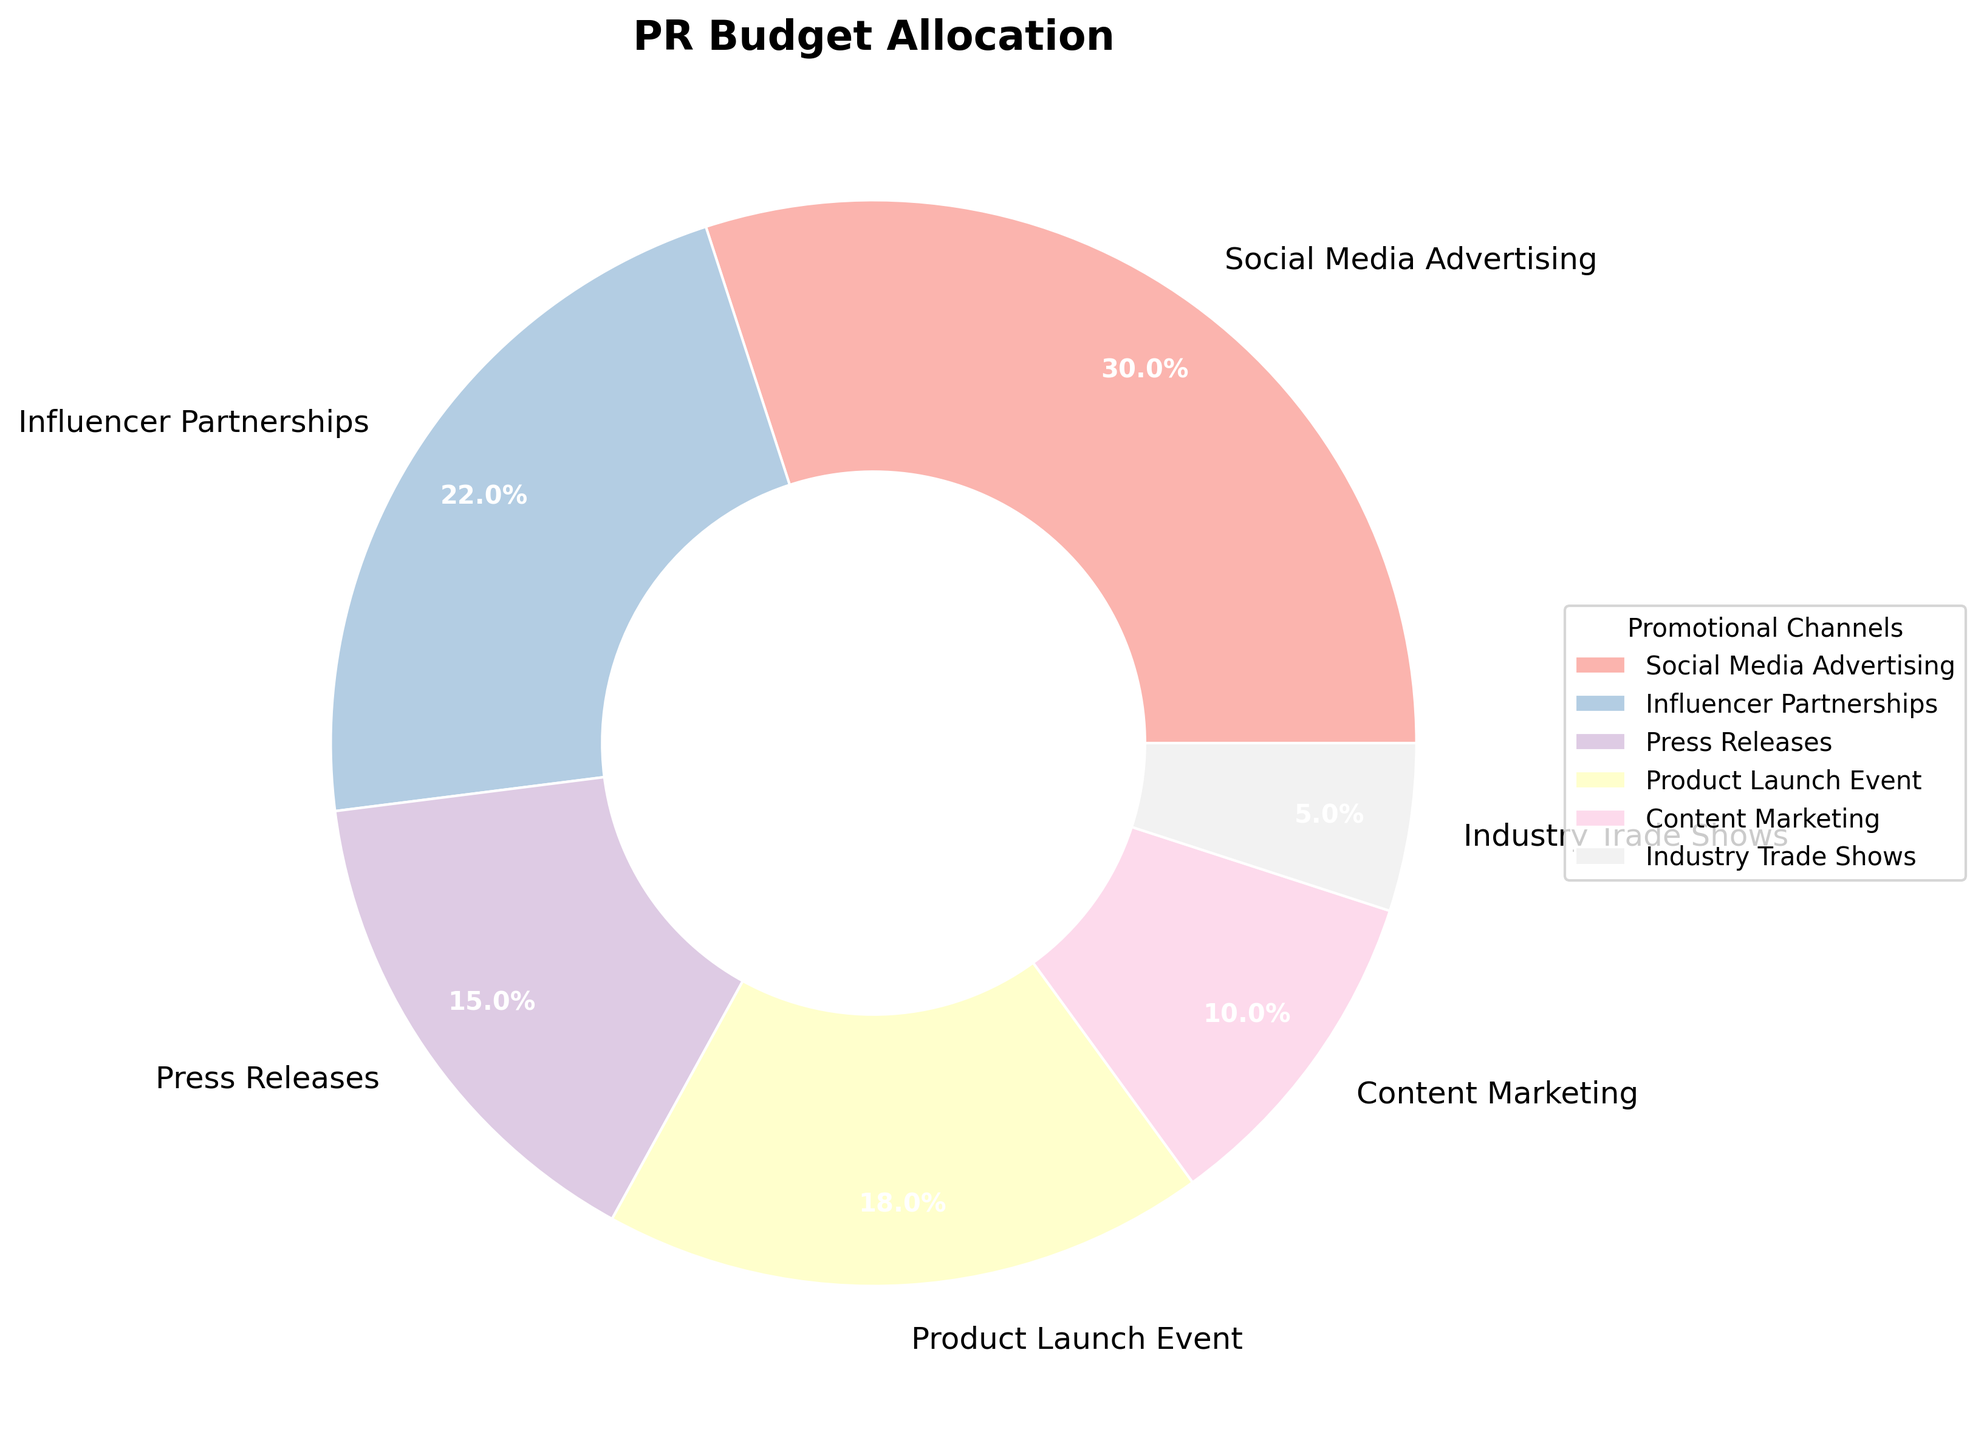What's the largest percentage among the channels? By observing the figure, the largest percentage segment represents Social Media Advertising. This can be identified by the size of the segment and the percentage displayed in the pie chart.
Answer: Social Media Advertising (30%) What's the combined budget allocation for Social Media Advertising and Influencer Partnerships? Adding the individual percentages of Social Media Advertising (30%) and Influencer Partnerships (22%) yields 52%.
Answer: 52% Which channel has the smallest budget allocation? The segment with the smallest percentage displayed in the figure represents Industry Trade Shows.
Answer: Industry Trade Shows (5%) How much more is allocated to Social Media Advertising compared to Press Releases? The budget allocation for Social Media Advertising is 30%, and for Press Releases, it is 15%. Subtracting these values gives us the difference: 30% - 15% = 15%.
Answer: 15% What is the average budget allocation across all channels? Adding the budget allocations for all channels: Social Media Advertising (30%), Influencer Partnerships (22%), Press Releases (15%), Product Launch Event (18%), Content Marketing (10%), and Industry Trade Shows (5%), gives us a total of 100%. Dividing by the number of channels (6) gives the average: 100% / 6 ≈ 16.67%.
Answer: 16.67% Is the budget for Product Launch Event greater than Content Marketing? By how much? The budget for Product Launch Event is 18%, while Content Marketing is 10%. Subtracting the two values: 18% - 10% = 8%. Thus, Product Launch Event has 8% more allocation.
Answer: 8% What percentage of the budget is allocated to channels other than Social Media Advertising? Subtracting the Social Media Advertising allocation (30%) from 100% we get: 100% - 30% = 70%.
Answer: 70% How many channels have a budget allocation of more than 15%? By observing the figure, Social Media Advertising (30%), Influencer Partnerships (22%), and Product Launch Event (18%) are the only channels with more than 15% allocation. This counts up to three channels.
Answer: 3 